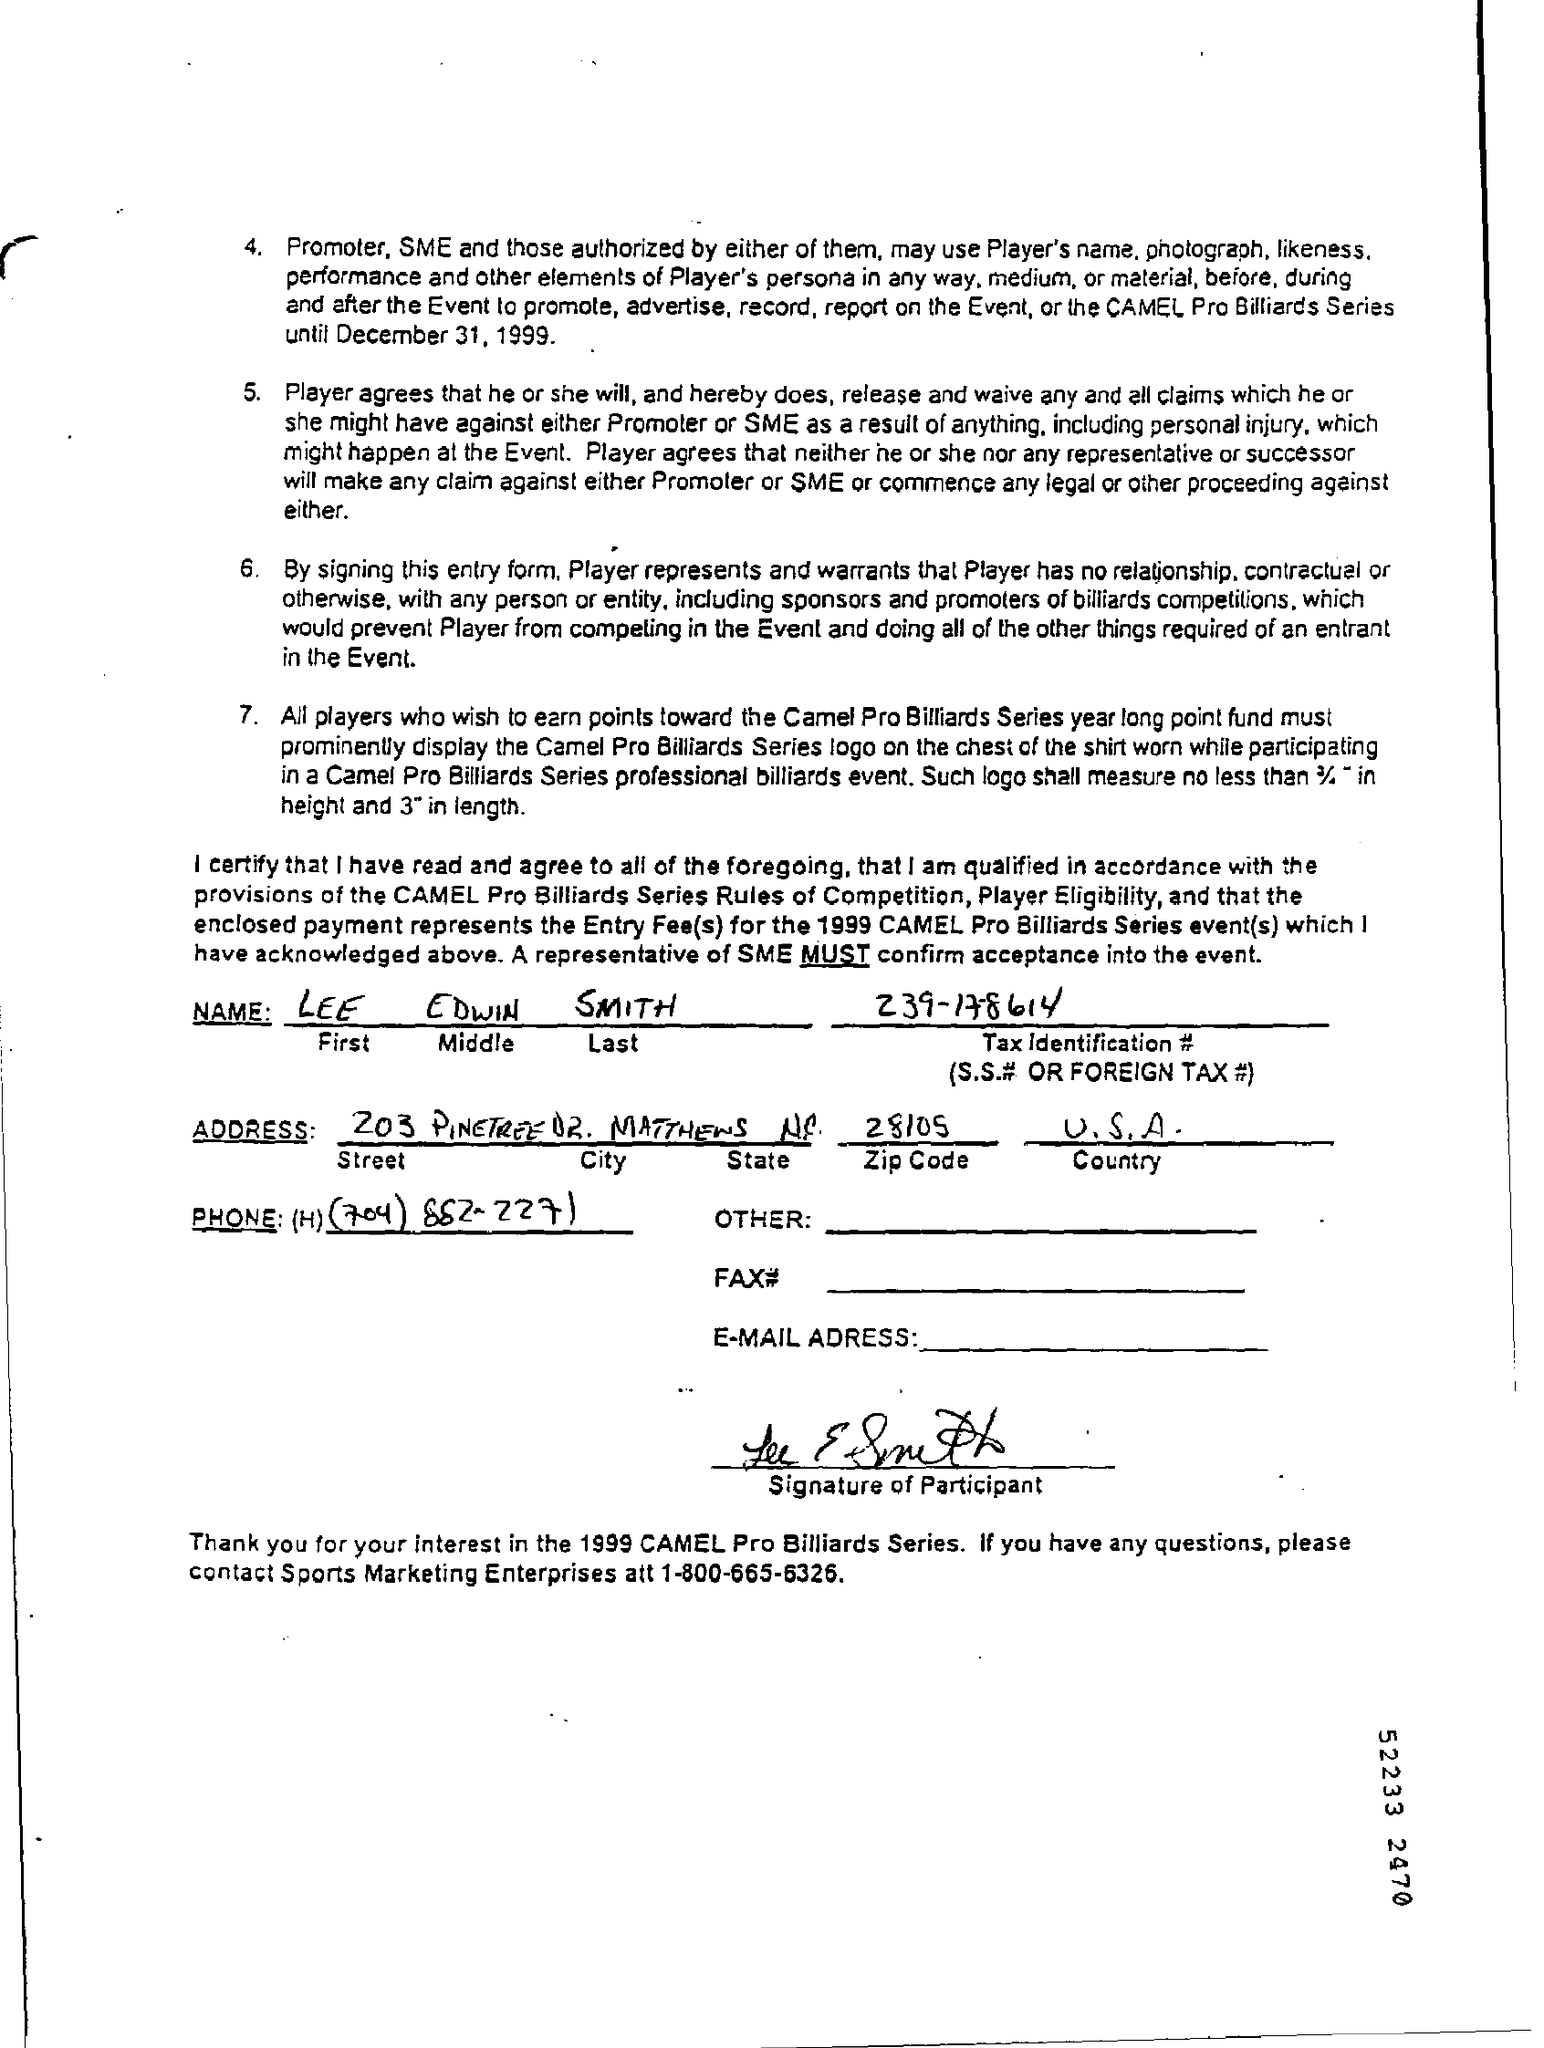What is the name mentioned ?
Provide a succinct answer. Lee Edwin Smith. What is the tax identification # (s.s. # or foreign tax # )
Your answer should be very brief. 239-178614. To which country it belongs to?
Provide a short and direct response. U.S.A. What is the Zip code
Provide a short and direct response. 28105. What is the phone number of sports marketing enterprises ?
Give a very brief answer. 1-800-665-6326. 